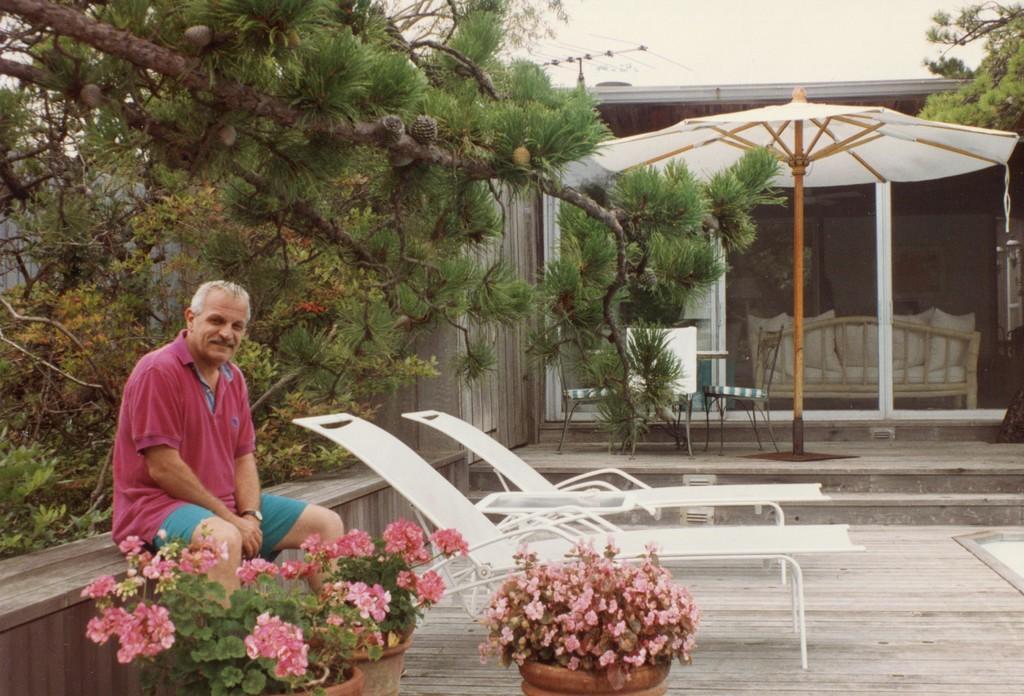Please provide a concise description of this image. On the left side of the image we can see one person is sitting and he is smiling, which we can see on his face. And we can see outdoor relaxing chairs, plant pots, plants, flowers, etc. In the background, we can see the sky, clouds, one building, trees, chairs, poles, one couch, one outdoor umbrella and a few other objects. 